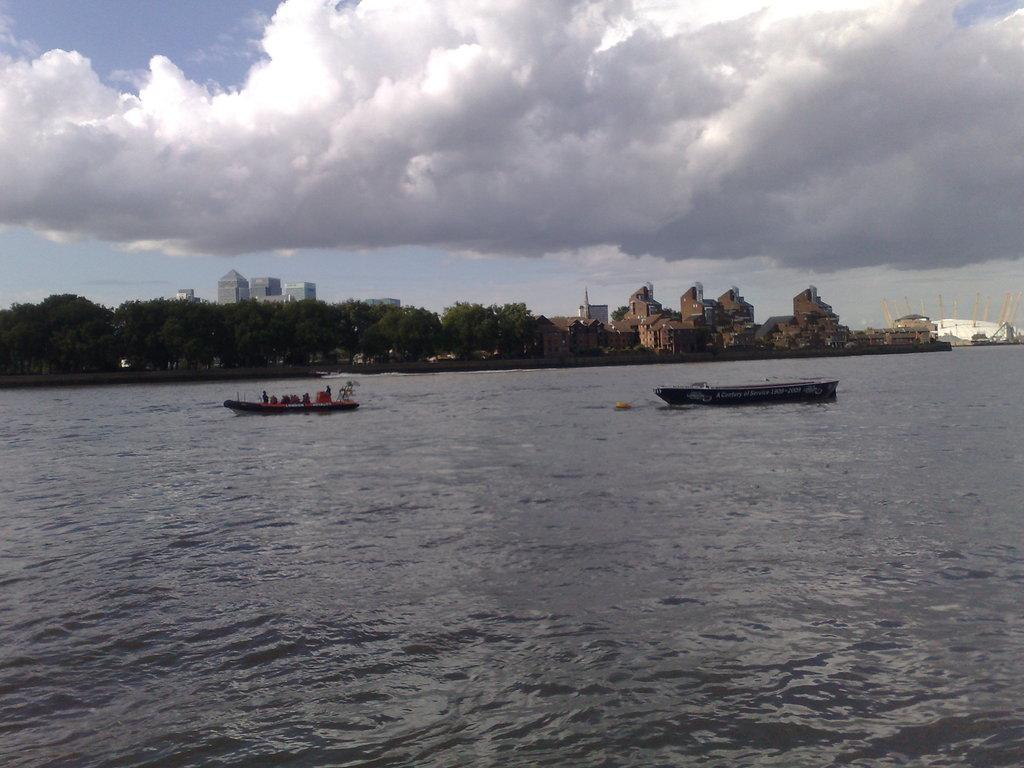What is happening in the image? There are boats sailing in the image. Where are the boats located? The boats are on water. What can be seen in the background of the image? There are trees and buildings in the background of the image. How would you describe the weather in the image? The sky is cloudy in the image. What type of coat is the rose wearing in the image? There is no rose or coat present in the image. 